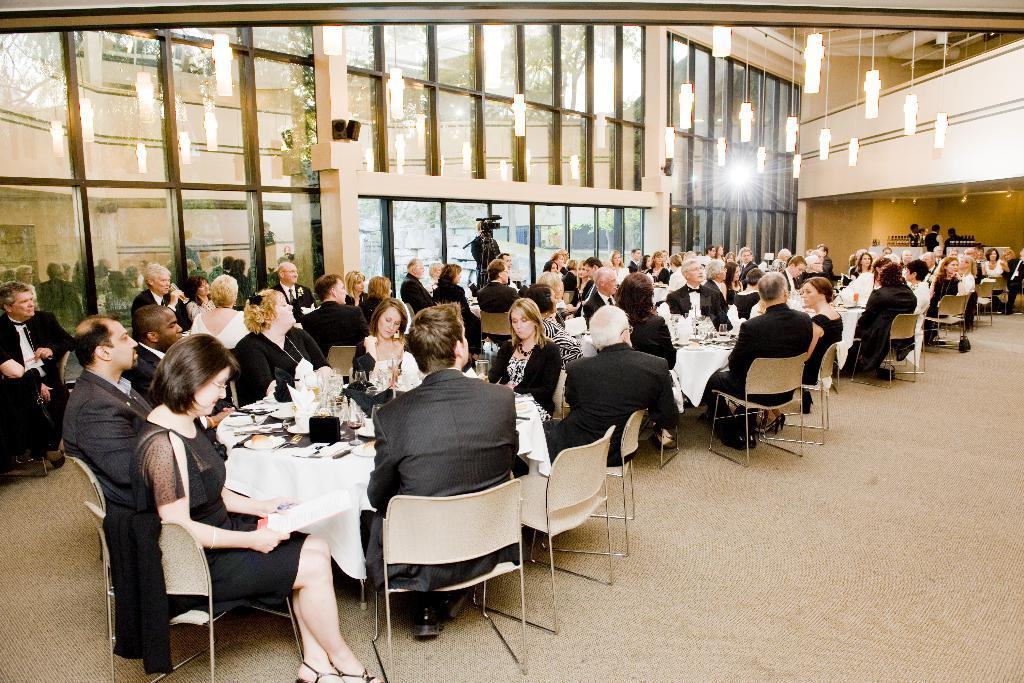What is the main subject of the image? The main subject of the image is a group of people. What are the people in the image doing? The people are seated on chairs. Is there anyone standing in the image? Yes, there is a man standing in the image. What is the man holding in the image? The man is holding a camera. What can be seen in the background of the image? There is a light visible in the image. What type of stretch can be seen in the image? There is no stretch visible in the image. Can you recite a verse from the poem that is present in the image? There is no poem or verse present in the image. 